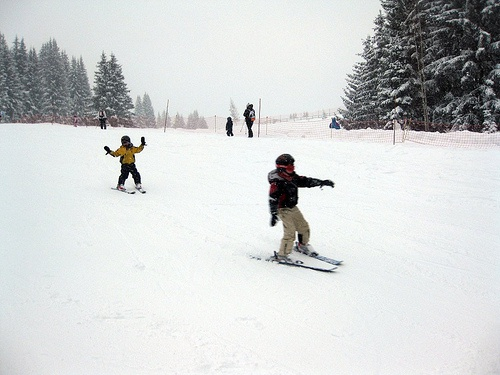Describe the objects in this image and their specific colors. I can see people in lightgray, black, gray, white, and darkgray tones, people in lightgray, black, olive, and white tones, skis in lightgray, darkgray, gray, and black tones, people in lightgray, black, gray, darkgray, and white tones, and people in lightgray, black, gray, and darkgray tones in this image. 